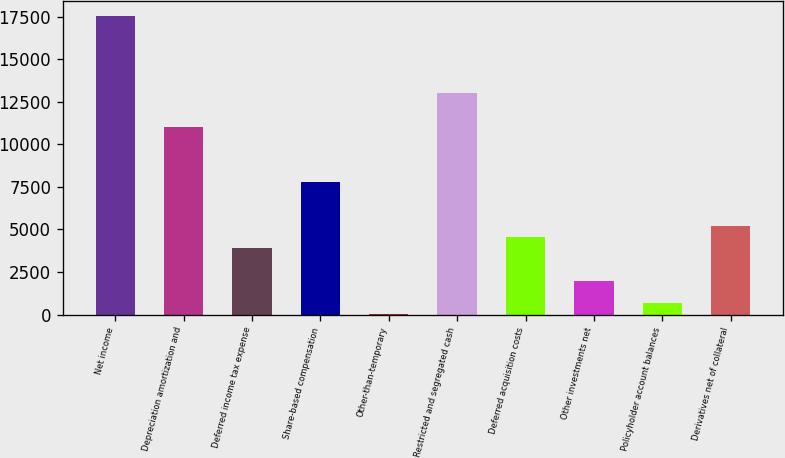Convert chart. <chart><loc_0><loc_0><loc_500><loc_500><bar_chart><fcel>Net income<fcel>Depreciation amortization and<fcel>Deferred income tax expense<fcel>Share-based compensation<fcel>Other-than-temporary<fcel>Restricted and segregated cash<fcel>Deferred acquisition costs<fcel>Other investments net<fcel>Policyholder account balances<fcel>Derivatives net of collateral<nl><fcel>17537.8<fcel>11043.8<fcel>3900.4<fcel>7796.8<fcel>4<fcel>12992<fcel>4549.8<fcel>1952.2<fcel>653.4<fcel>5199.2<nl></chart> 